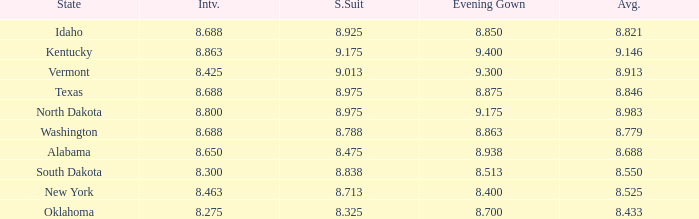What is the lowest evening score of the contestant with an evening gown less than 8.938, from Texas, and with an average less than 8.846 has? None. 